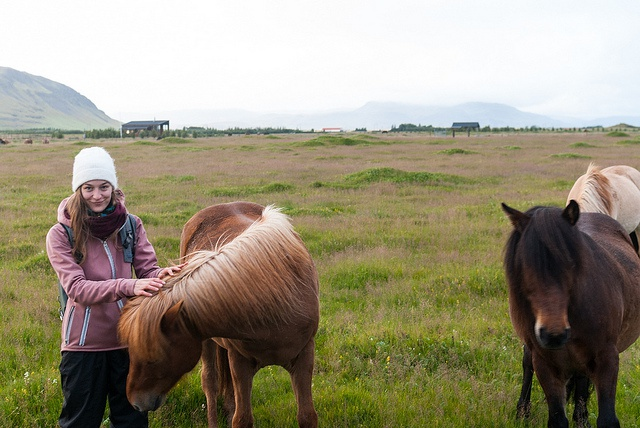Describe the objects in this image and their specific colors. I can see horse in white, black, maroon, and brown tones, horse in white, black, maroon, gray, and olive tones, people in white, black, brown, and lightgray tones, horse in white, darkgray, and lightgray tones, and backpack in white, black, gray, and blue tones in this image. 